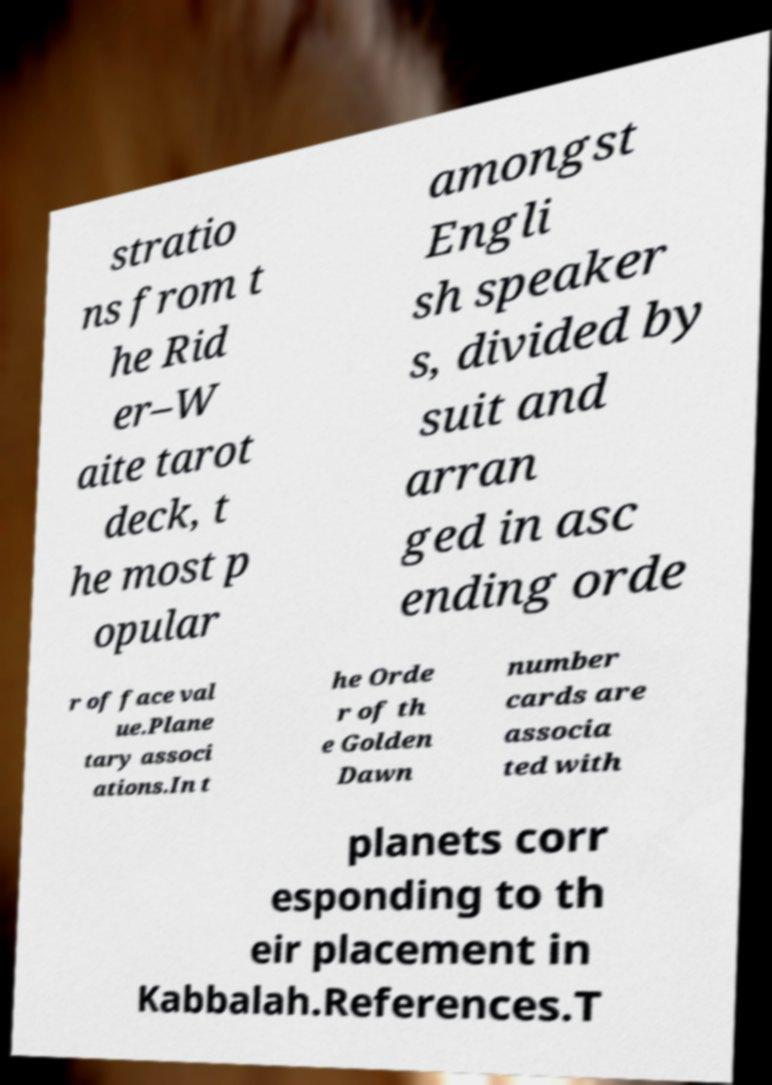For documentation purposes, I need the text within this image transcribed. Could you provide that? stratio ns from t he Rid er–W aite tarot deck, t he most p opular amongst Engli sh speaker s, divided by suit and arran ged in asc ending orde r of face val ue.Plane tary associ ations.In t he Orde r of th e Golden Dawn number cards are associa ted with planets corr esponding to th eir placement in Kabbalah.References.T 